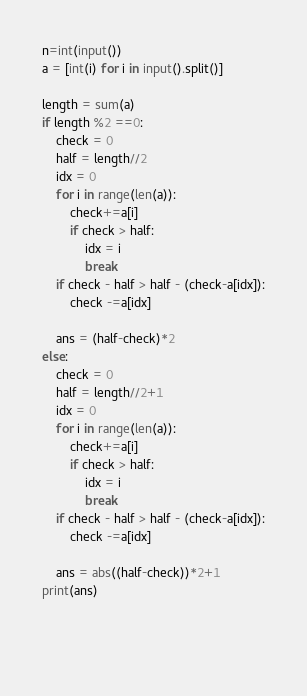<code> <loc_0><loc_0><loc_500><loc_500><_Python_>n=int(input())
a = [int(i) for i in input().split()]

length = sum(a)
if length %2 ==0:
    check = 0
    half = length//2
    idx = 0
    for i in range(len(a)):
        check+=a[i]
        if check > half:
            idx = i
            break
    if check - half > half - (check-a[idx]):
        check -=a[idx]
    
    ans = (half-check)*2
else:
    check = 0
    half = length//2+1
    idx = 0
    for i in range(len(a)):
        check+=a[i]
        if check > half:
            idx = i
            break
    if check - half > half - (check-a[idx]):
        check -=a[idx]
    
    ans = abs((half-check))*2+1
print(ans)
    
                
            </code> 